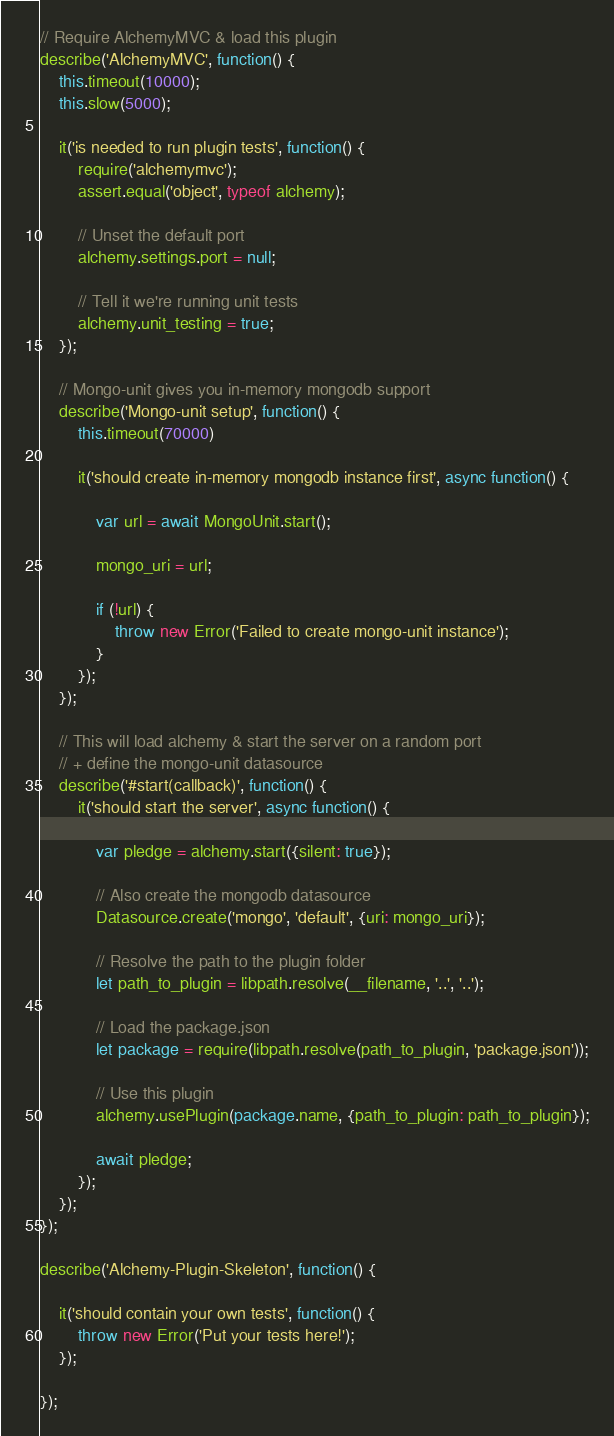<code> <loc_0><loc_0><loc_500><loc_500><_JavaScript_>// Require AlchemyMVC & load this plugin
describe('AlchemyMVC', function() {
	this.timeout(10000);
	this.slow(5000);

	it('is needed to run plugin tests', function() {
		require('alchemymvc');
		assert.equal('object', typeof alchemy);

		// Unset the default port
		alchemy.settings.port = null;

		// Tell it we're running unit tests
		alchemy.unit_testing = true;
	});

	// Mongo-unit gives you in-memory mongodb support
	describe('Mongo-unit setup', function() {
		this.timeout(70000)

		it('should create in-memory mongodb instance first', async function() {

			var url = await MongoUnit.start();

			mongo_uri = url;

			if (!url) {
				throw new Error('Failed to create mongo-unit instance');
			}
		});
	});

	// This will load alchemy & start the server on a random port
	// + define the mongo-unit datasource
	describe('#start(callback)', function() {
		it('should start the server', async function() {

			var pledge = alchemy.start({silent: true});

			// Also create the mongodb datasource
			Datasource.create('mongo', 'default', {uri: mongo_uri});

			// Resolve the path to the plugin folder
			let path_to_plugin = libpath.resolve(__filename, '..', '..');

			// Load the package.json
			let package = require(libpath.resolve(path_to_plugin, 'package.json'));

			// Use this plugin
			alchemy.usePlugin(package.name, {path_to_plugin: path_to_plugin});

			await pledge;
		});
	});
});

describe('Alchemy-Plugin-Skeleton', function() {

	it('should contain your own tests', function() {
		throw new Error('Put your tests here!');
	});

});</code> 